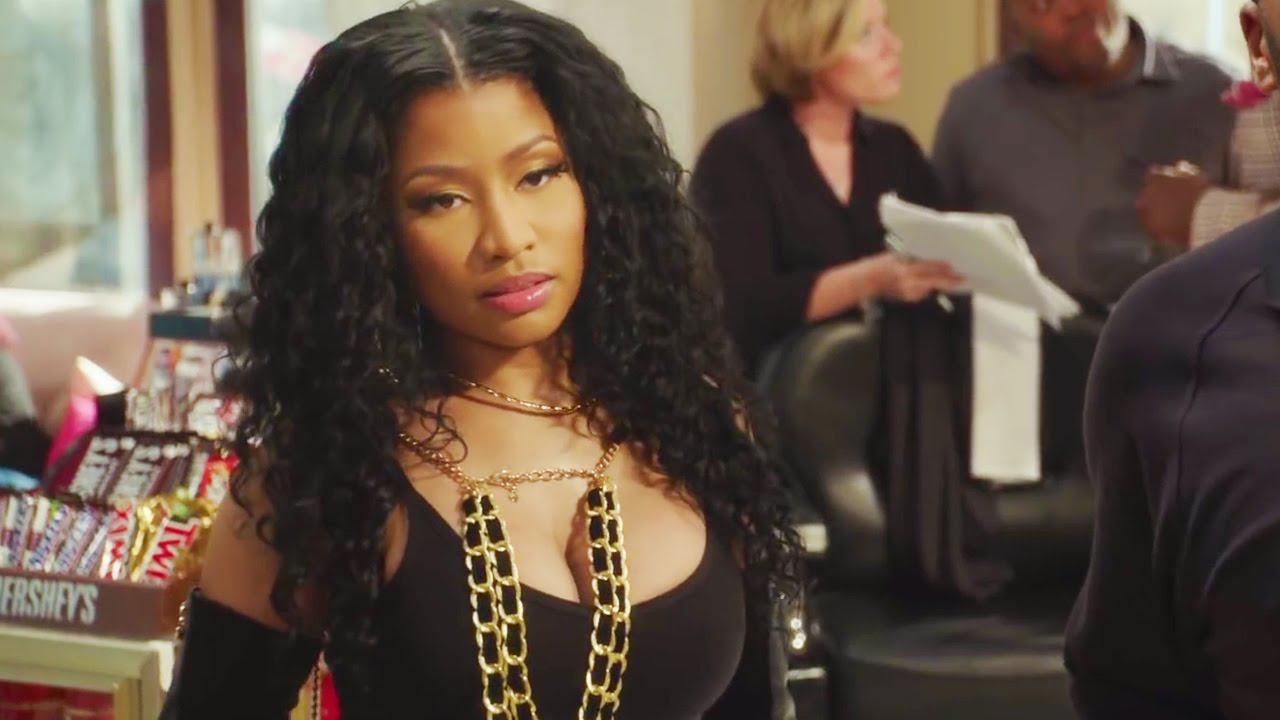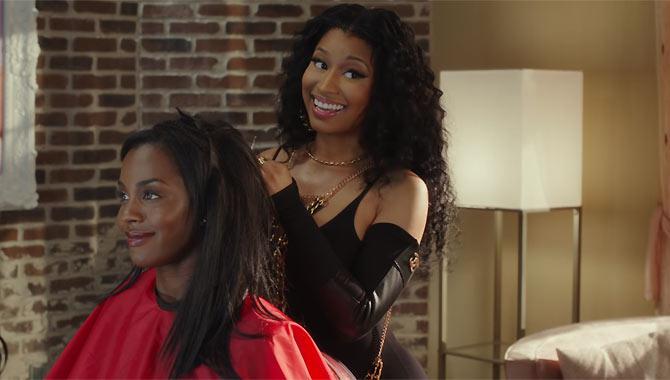The first image is the image on the left, the second image is the image on the right. Examine the images to the left and right. Is the description "Only men are present in one of the barbershop images." accurate? Answer yes or no. No. The first image is the image on the left, the second image is the image on the right. Evaluate the accuracy of this statement regarding the images: "There is a woman in red in one of the images.". Is it true? Answer yes or no. Yes. 